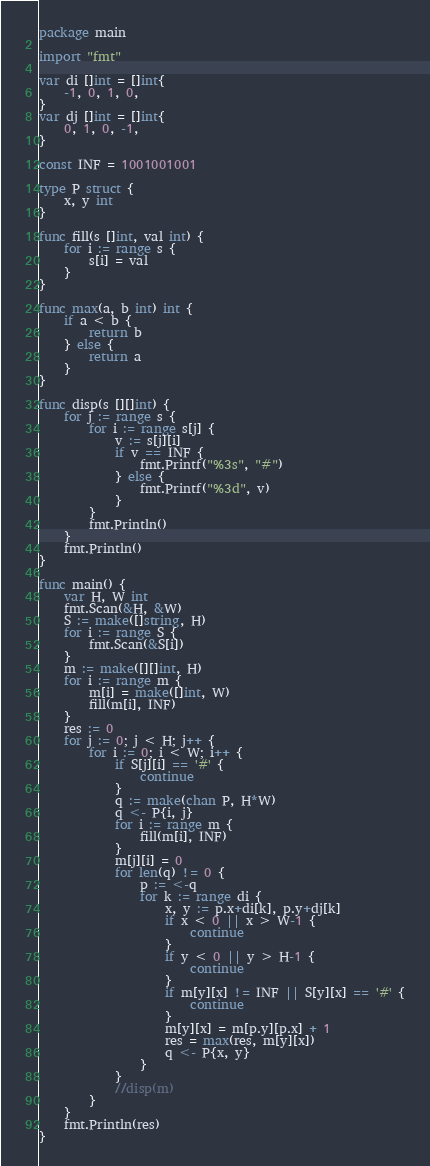<code> <loc_0><loc_0><loc_500><loc_500><_Go_>package main

import "fmt"

var di []int = []int{
	-1, 0, 1, 0,
}
var dj []int = []int{
	0, 1, 0, -1,
}

const INF = 1001001001

type P struct {
	x, y int
}

func fill(s []int, val int) {
	for i := range s {
		s[i] = val
	}
}

func max(a, b int) int {
	if a < b {
		return b
	} else {
		return a
	}
}

func disp(s [][]int) {
	for j := range s {
		for i := range s[j] {
			v := s[j][i]
			if v == INF {
				fmt.Printf("%3s", "#")
			} else {
				fmt.Printf("%3d", v)
			}
		}
		fmt.Println()
	}
	fmt.Println()
}

func main() {
	var H, W int
	fmt.Scan(&H, &W)
	S := make([]string, H)
	for i := range S {
		fmt.Scan(&S[i])
	}
	m := make([][]int, H)
	for i := range m {
		m[i] = make([]int, W)
		fill(m[i], INF)
	}
	res := 0
	for j := 0; j < H; j++ {
		for i := 0; i < W; i++ {
			if S[j][i] == '#' {
				continue
			}
			q := make(chan P, H*W)
			q <- P{i, j}
			for i := range m {
				fill(m[i], INF)
			}
			m[j][i] = 0
			for len(q) != 0 {
				p := <-q
				for k := range di {
					x, y := p.x+di[k], p.y+dj[k]
					if x < 0 || x > W-1 {
						continue
					}
					if y < 0 || y > H-1 {
						continue
					}
					if m[y][x] != INF || S[y][x] == '#' {
						continue
					}
					m[y][x] = m[p.y][p.x] + 1
					res = max(res, m[y][x])
					q <- P{x, y}
				}
			}
			//disp(m)
		}
	}
	fmt.Println(res)
}
</code> 